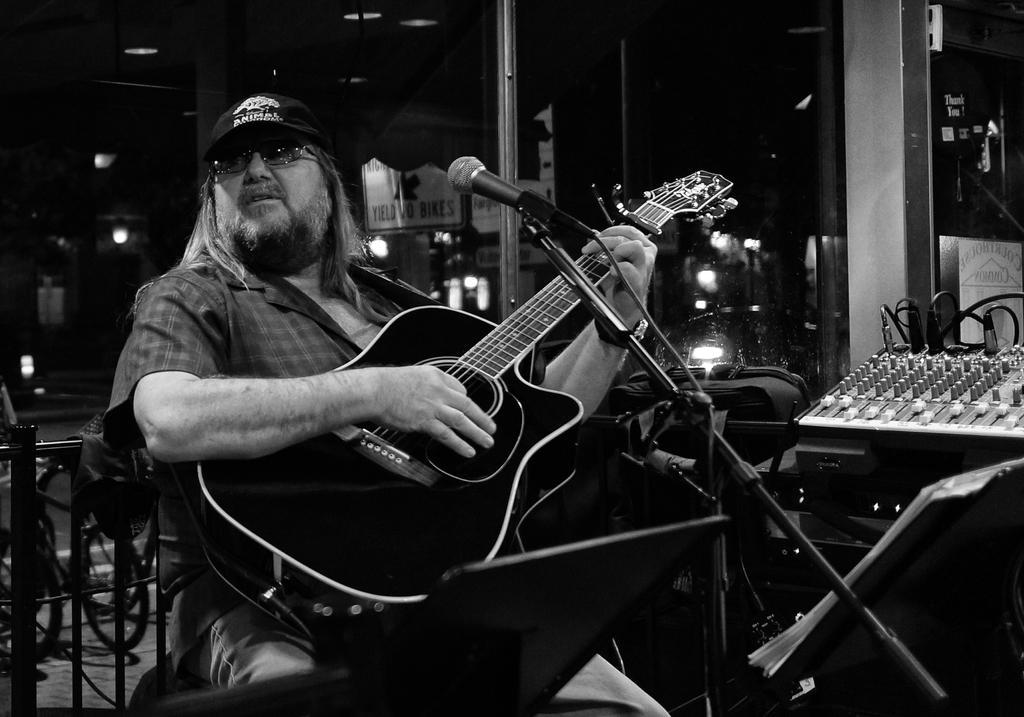Could you give a brief overview of what you see in this image? In the center of the picture a man is seated and playing guitar. On the right there are music and volume adjuster. In the background there are buildings and lights. On the left there is railing and bicycle. In the center there is microphone. 